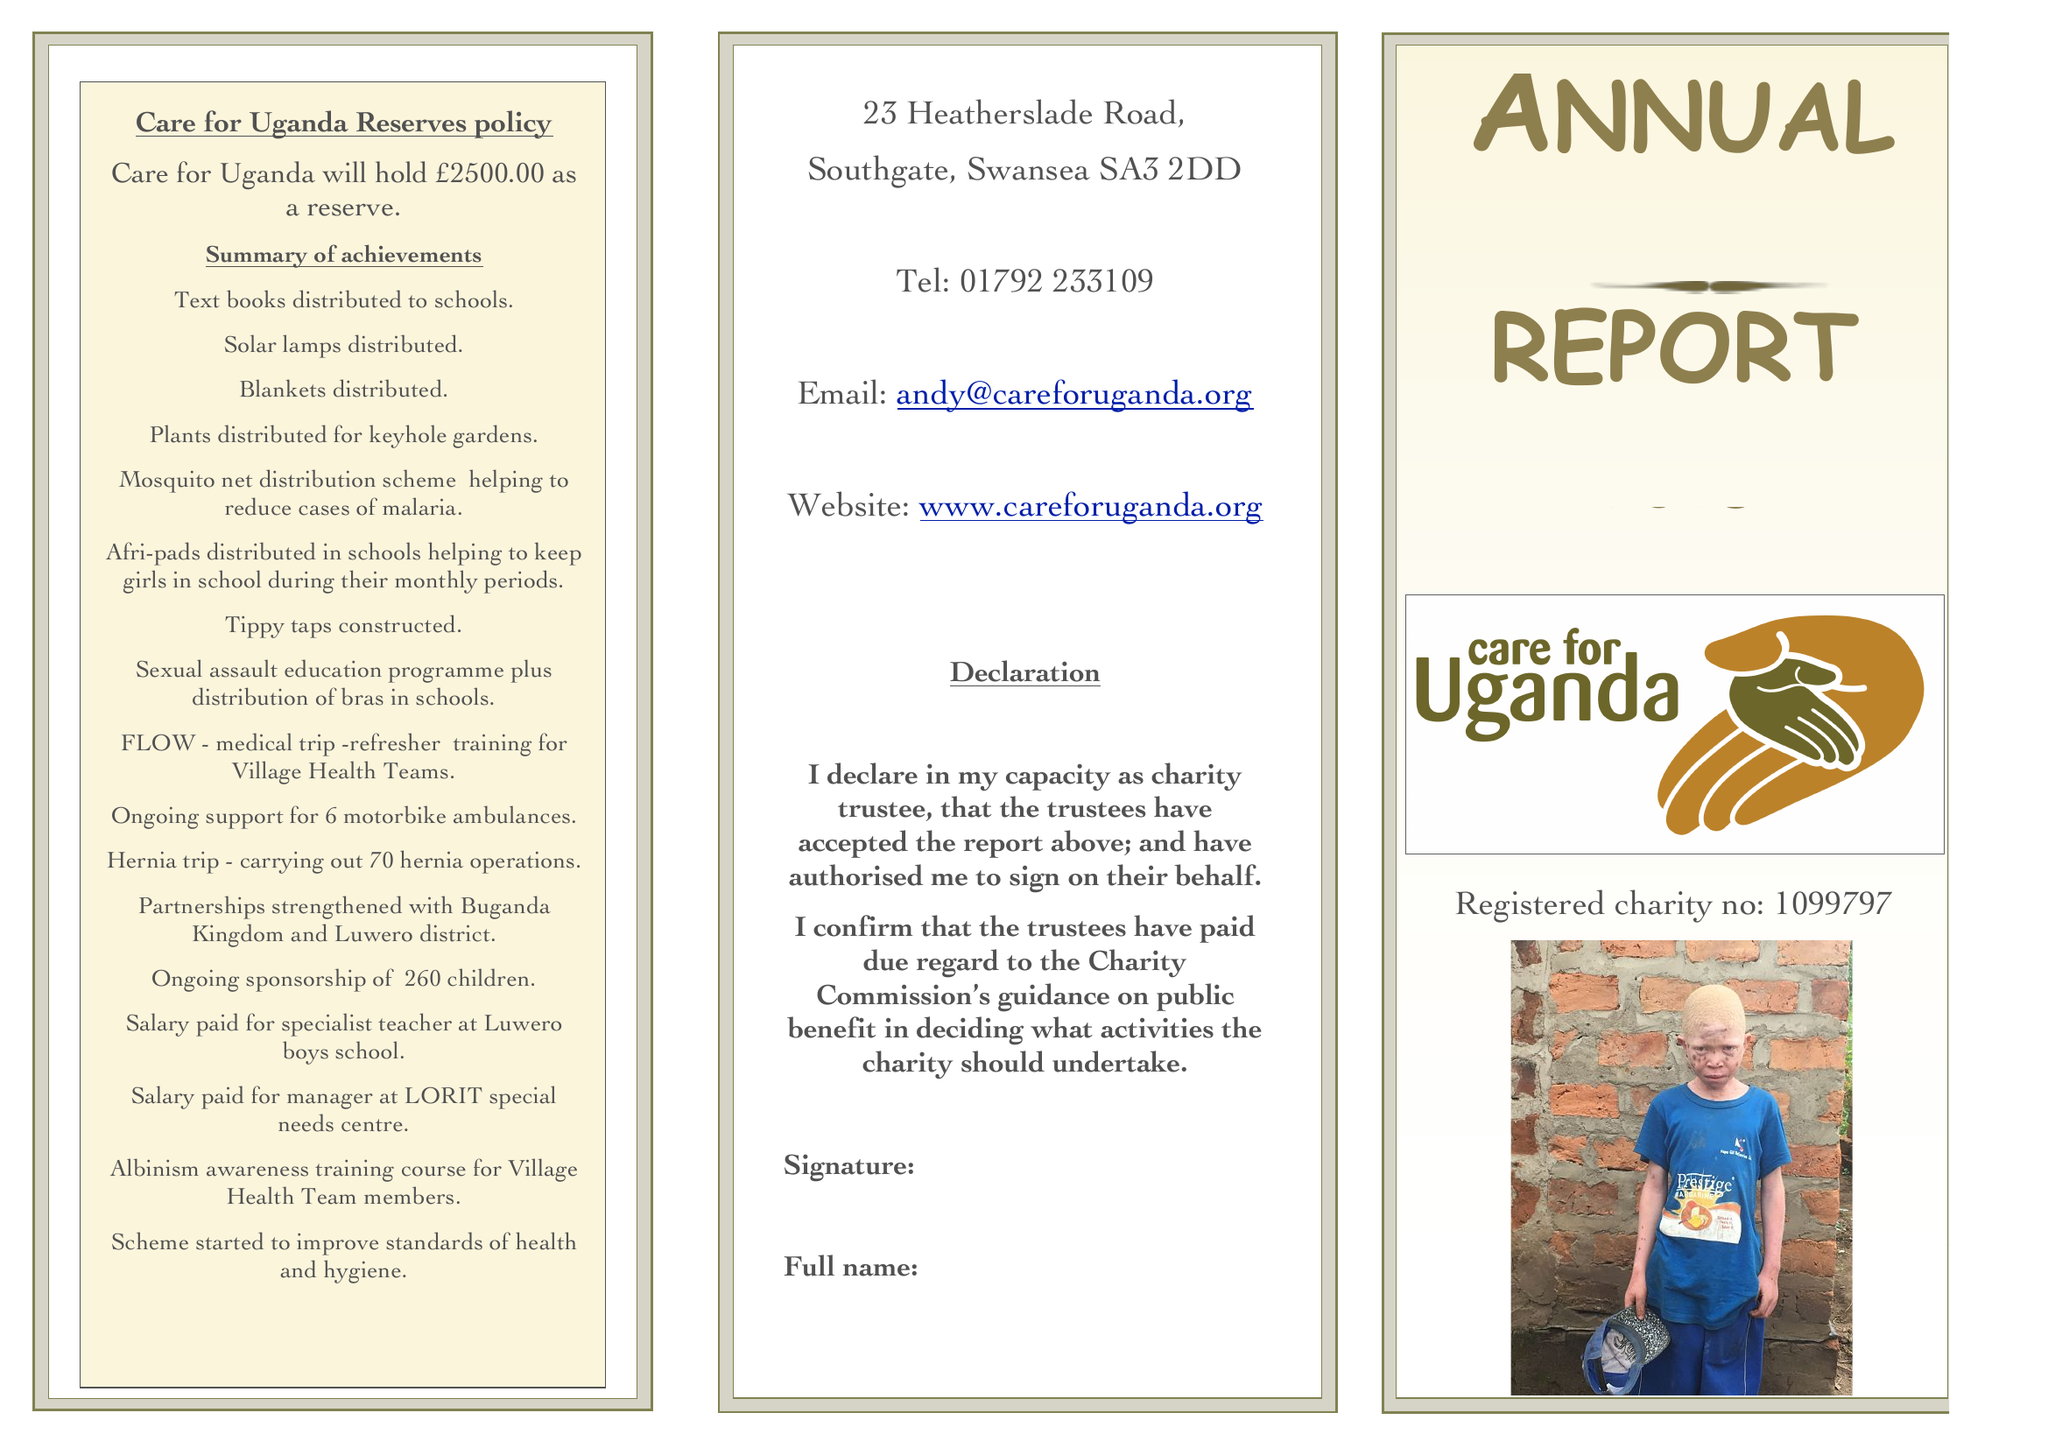What is the value for the address__street_line?
Answer the question using a single word or phrase. 23 HEATHERSLADE ROAD 